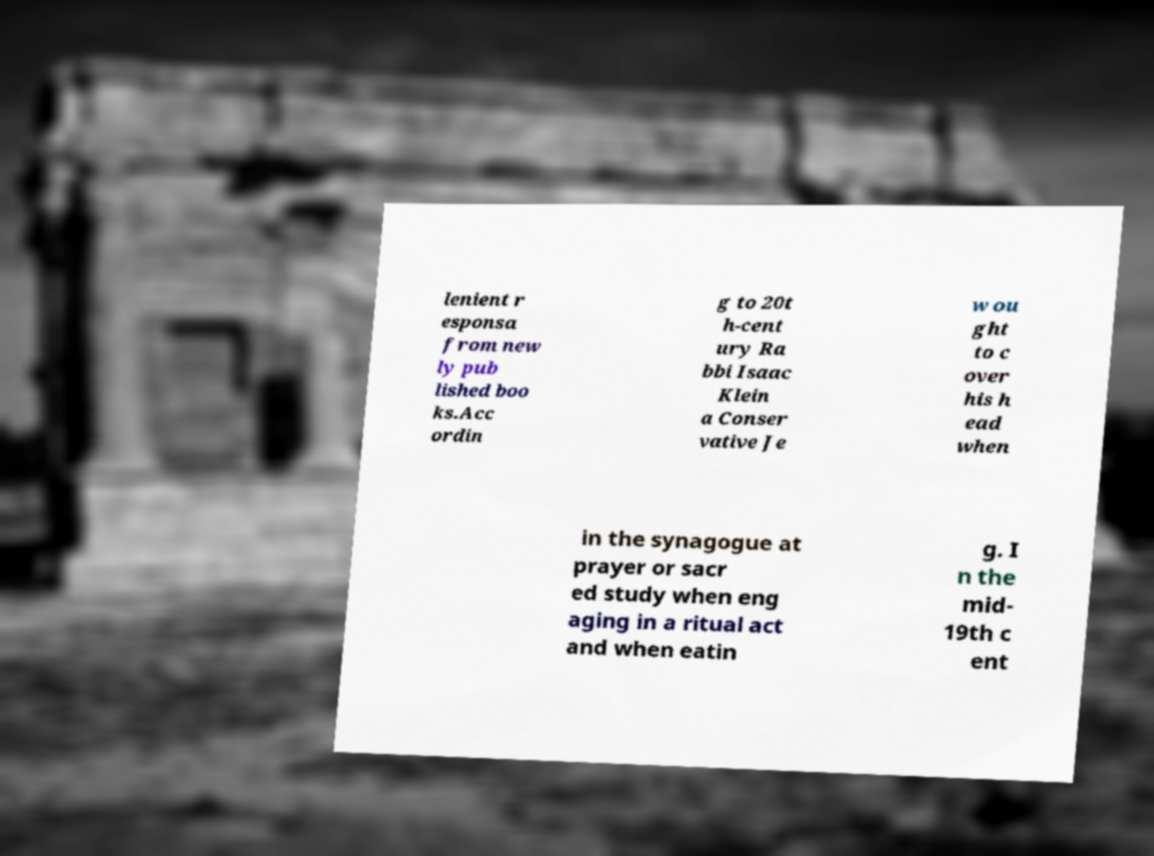Could you extract and type out the text from this image? lenient r esponsa from new ly pub lished boo ks.Acc ordin g to 20t h-cent ury Ra bbi Isaac Klein a Conser vative Je w ou ght to c over his h ead when in the synagogue at prayer or sacr ed study when eng aging in a ritual act and when eatin g. I n the mid- 19th c ent 